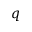Convert formula to latex. <formula><loc_0><loc_0><loc_500><loc_500>q</formula> 